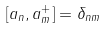<formula> <loc_0><loc_0><loc_500><loc_500>[ a _ { n } , a _ { m } ^ { + } ] = \delta _ { n m }</formula> 